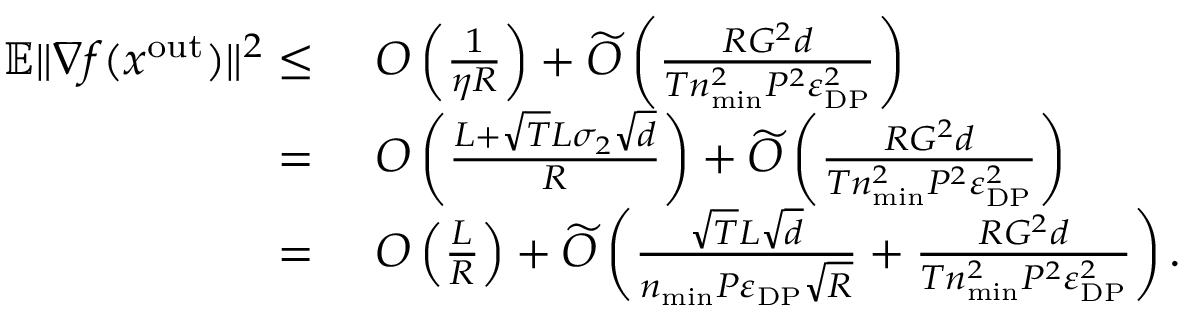Convert formula to latex. <formula><loc_0><loc_0><loc_500><loc_500>\begin{array} { r l } { \mathbb { E } \| \nabla f ( x ^ { o u t } ) \| ^ { 2 } \leq } & { \ O \left ( \frac { 1 } { \eta R } \right ) + \widetilde { O } \left ( \frac { R G ^ { 2 } d } { T n _ { \min } ^ { 2 } P ^ { 2 } \varepsilon _ { D P } ^ { 2 } } \right ) } \\ { = } & { \ O \left ( \frac { L + \sqrt { T } L \sigma _ { 2 } \sqrt { d } } { R } \right ) + \widetilde { O } \left ( \frac { R G ^ { 2 } d } { T n _ { \min } ^ { 2 } P ^ { 2 } \varepsilon _ { D P } ^ { 2 } } \right ) } \\ { = } & { \ O \left ( \frac { L } { R } \right ) + \widetilde { O } \left ( \frac { \sqrt { T } L \sqrt { d } } { n _ { \min } P \varepsilon _ { D P } \sqrt { R } } + \frac { R G ^ { 2 } d } { T n _ { \min } ^ { 2 } P ^ { 2 } \varepsilon _ { D P } ^ { 2 } } \right ) . } \end{array}</formula> 